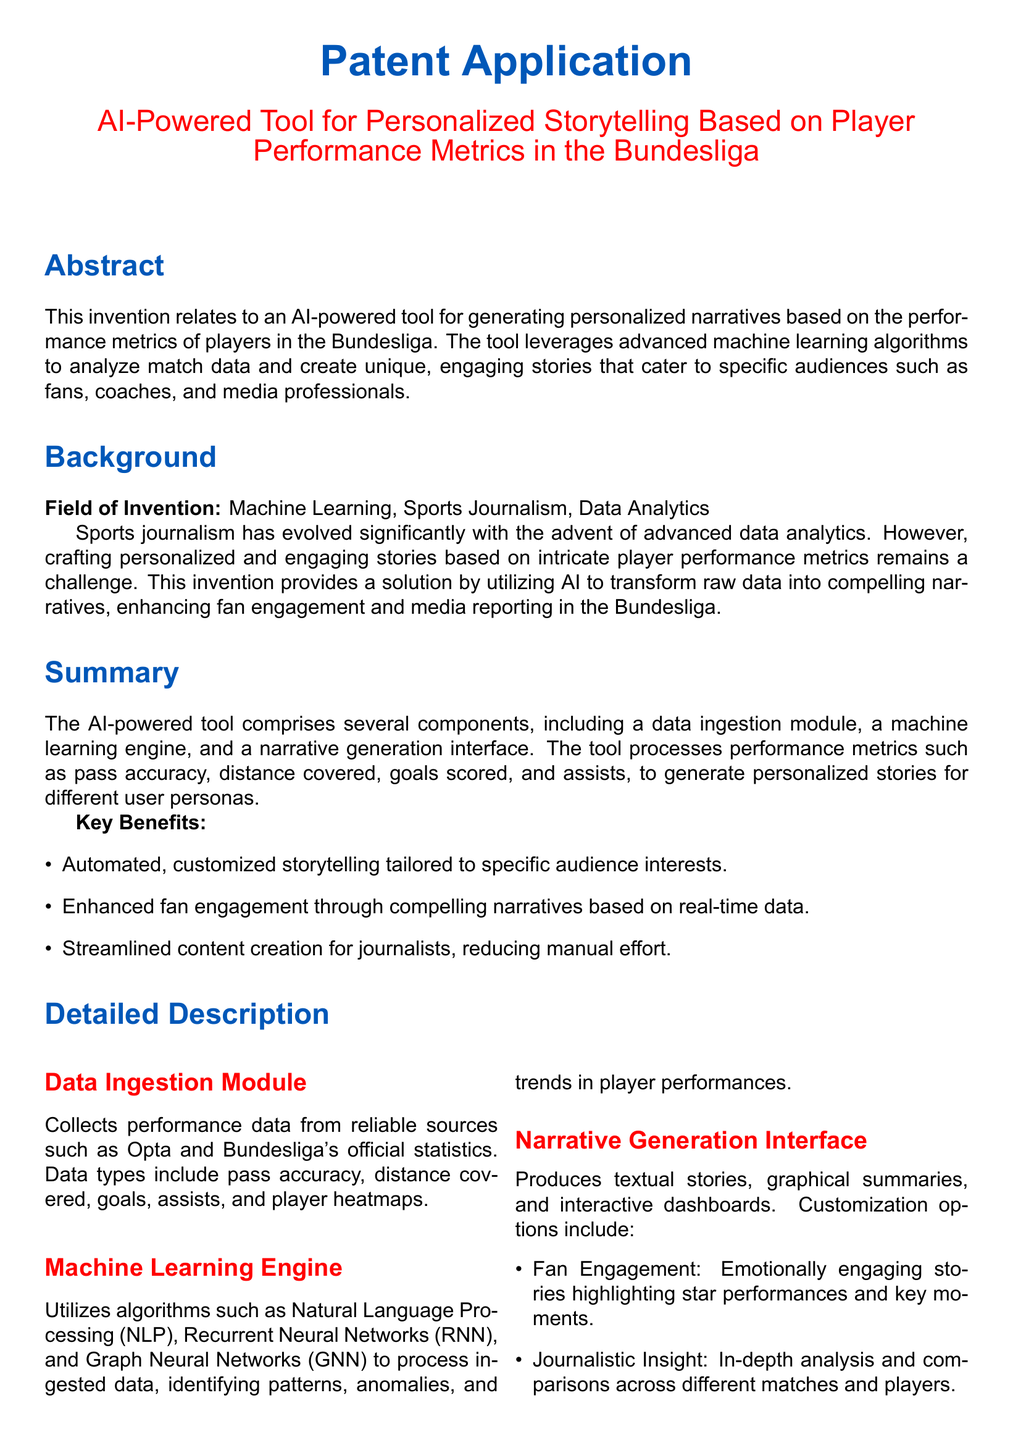What is the main purpose of the invention? The invention aims to generate personalized narratives based on player performance metrics in the Bundesliga.
Answer: Generating personalized narratives What data sources does the tool utilize? The data ingestion module collects performance data from reliable sources such as Opta and Bundesliga's official statistics.
Answer: Opta and Bundesliga's official statistics What performance metrics are processed by the tool? The tool processes performance metrics such as pass accuracy, distance covered, goals scored, and assists.
Answer: Pass accuracy, distance covered, goals scored, assists Which machine learning algorithms are used in the tool? The machine learning engine utilizes algorithms such as Natural Language Processing (NLP), Recurrent Neural Networks (RNN), and Graph Neural Networks (GNN).
Answer: NLP, RNN, GNN What is one key benefit of the AI-powered tool? One key benefit is enhanced fan engagement through compelling narratives based on real-time data.
Answer: Enhanced fan engagement What type of insights does the narrative generation interface provide for journalists? The interface provides in-depth analysis and comparisons across different matches and players.
Answer: In-depth analysis and comparisons Which player's performance is highlighted in the fan engagement example? The fan engagement example highlights Robert Lewandowski's performance.
Answer: Robert Lewandowski What does the coaching strategy analysis focus on according to the document? It evaluates Alphonso Davies' heatmaps to inform coaching decisions.
Answer: Alphonso Davies' heatmaps How does the invention impact sports journalism? It streamlines content creation for journalists, reducing manual effort.
Answer: Streamlines content creation 